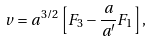Convert formula to latex. <formula><loc_0><loc_0><loc_500><loc_500>v = a ^ { 3 / 2 } \left [ F _ { 3 } - \frac { a } { a ^ { \prime } } F _ { 1 } \right ] ,</formula> 